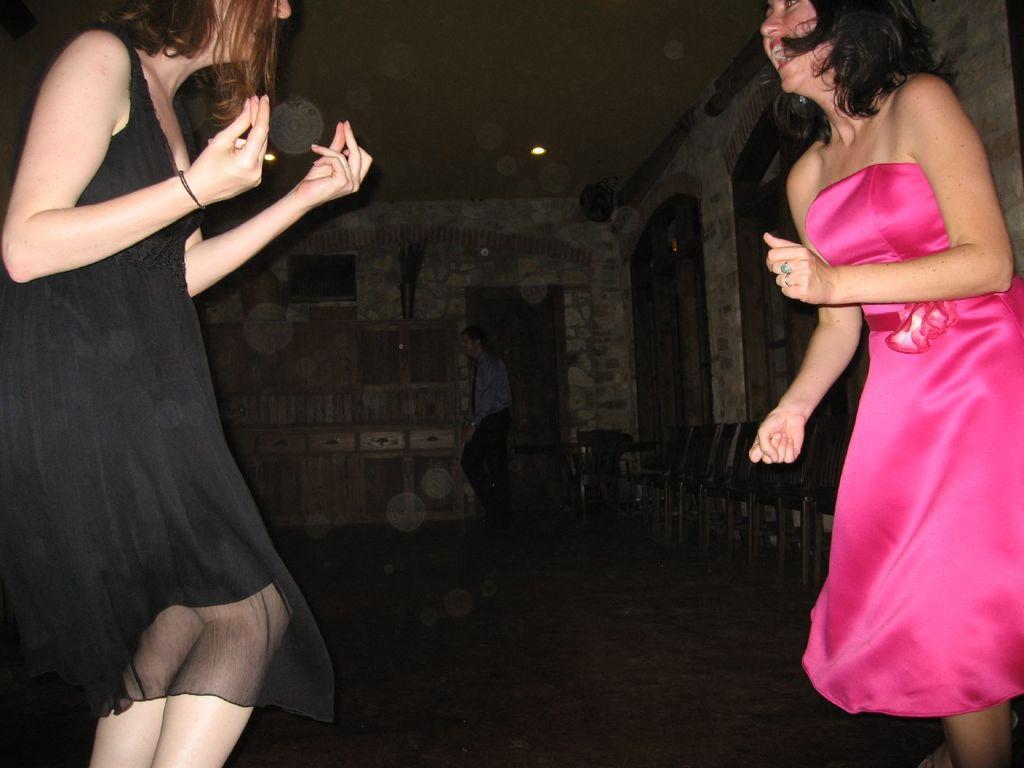How would you summarize this image in a sentence or two? In the image we can see two women, wearing clothes and they are smiling, and it looks like they are dancing. Here we can see chairs and the background is dark. 